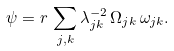Convert formula to latex. <formula><loc_0><loc_0><loc_500><loc_500>\psi = r \, \sum _ { j , k } \lambda ^ { - 2 } _ { j k } \, \Omega _ { j k } \, \omega _ { j k } .</formula> 